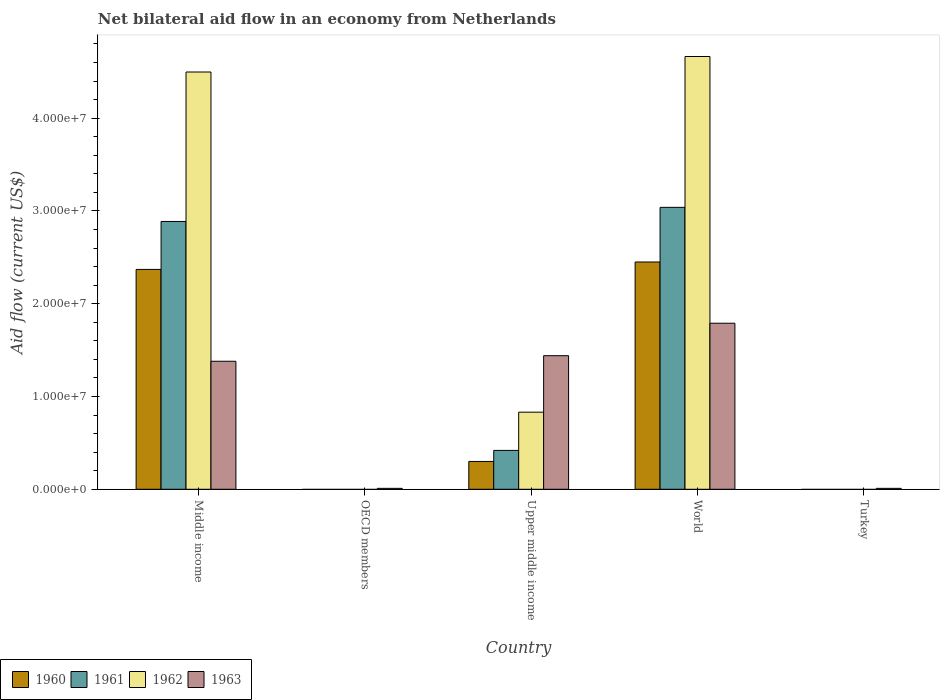How many different coloured bars are there?
Your response must be concise. 4. How many bars are there on the 4th tick from the left?
Your answer should be very brief. 4. How many bars are there on the 1st tick from the right?
Give a very brief answer. 1. What is the label of the 3rd group of bars from the left?
Make the answer very short. Upper middle income. In how many cases, is the number of bars for a given country not equal to the number of legend labels?
Offer a terse response. 2. What is the net bilateral aid flow in 1963 in Upper middle income?
Provide a succinct answer. 1.44e+07. Across all countries, what is the maximum net bilateral aid flow in 1962?
Your answer should be very brief. 4.66e+07. Across all countries, what is the minimum net bilateral aid flow in 1960?
Provide a short and direct response. 0. In which country was the net bilateral aid flow in 1963 maximum?
Offer a terse response. World. What is the total net bilateral aid flow in 1963 in the graph?
Give a very brief answer. 4.63e+07. What is the difference between the net bilateral aid flow in 1960 in Middle income and that in World?
Give a very brief answer. -8.00e+05. What is the difference between the net bilateral aid flow in 1960 in Upper middle income and the net bilateral aid flow in 1963 in World?
Provide a succinct answer. -1.49e+07. What is the average net bilateral aid flow in 1963 per country?
Offer a very short reply. 9.26e+06. What is the difference between the net bilateral aid flow of/in 1961 and net bilateral aid flow of/in 1960 in Middle income?
Your answer should be very brief. 5.17e+06. What is the ratio of the net bilateral aid flow in 1963 in Turkey to that in World?
Give a very brief answer. 0.01. Is the difference between the net bilateral aid flow in 1961 in Middle income and World greater than the difference between the net bilateral aid flow in 1960 in Middle income and World?
Offer a terse response. No. What is the difference between the highest and the second highest net bilateral aid flow in 1961?
Ensure brevity in your answer.  2.62e+07. What is the difference between the highest and the lowest net bilateral aid flow in 1962?
Provide a short and direct response. 4.66e+07. In how many countries, is the net bilateral aid flow in 1960 greater than the average net bilateral aid flow in 1960 taken over all countries?
Make the answer very short. 2. Is the sum of the net bilateral aid flow in 1963 in Turkey and World greater than the maximum net bilateral aid flow in 1961 across all countries?
Provide a succinct answer. No. Is it the case that in every country, the sum of the net bilateral aid flow in 1960 and net bilateral aid flow in 1961 is greater than the net bilateral aid flow in 1962?
Ensure brevity in your answer.  No. How many bars are there?
Your answer should be very brief. 14. Are all the bars in the graph horizontal?
Ensure brevity in your answer.  No. Does the graph contain any zero values?
Offer a terse response. Yes. Does the graph contain grids?
Keep it short and to the point. No. Where does the legend appear in the graph?
Your answer should be compact. Bottom left. What is the title of the graph?
Your answer should be compact. Net bilateral aid flow in an economy from Netherlands. Does "2000" appear as one of the legend labels in the graph?
Keep it short and to the point. No. What is the label or title of the X-axis?
Offer a terse response. Country. What is the Aid flow (current US$) in 1960 in Middle income?
Your answer should be very brief. 2.37e+07. What is the Aid flow (current US$) in 1961 in Middle income?
Your answer should be compact. 2.89e+07. What is the Aid flow (current US$) of 1962 in Middle income?
Your answer should be very brief. 4.50e+07. What is the Aid flow (current US$) of 1963 in Middle income?
Offer a terse response. 1.38e+07. What is the Aid flow (current US$) in 1961 in OECD members?
Offer a very short reply. 0. What is the Aid flow (current US$) of 1962 in OECD members?
Your response must be concise. 0. What is the Aid flow (current US$) in 1963 in OECD members?
Your answer should be very brief. 1.00e+05. What is the Aid flow (current US$) in 1961 in Upper middle income?
Offer a terse response. 4.19e+06. What is the Aid flow (current US$) in 1962 in Upper middle income?
Keep it short and to the point. 8.31e+06. What is the Aid flow (current US$) in 1963 in Upper middle income?
Your answer should be very brief. 1.44e+07. What is the Aid flow (current US$) in 1960 in World?
Your response must be concise. 2.45e+07. What is the Aid flow (current US$) in 1961 in World?
Your answer should be very brief. 3.04e+07. What is the Aid flow (current US$) of 1962 in World?
Ensure brevity in your answer.  4.66e+07. What is the Aid flow (current US$) of 1963 in World?
Offer a terse response. 1.79e+07. What is the Aid flow (current US$) of 1961 in Turkey?
Offer a terse response. 0. Across all countries, what is the maximum Aid flow (current US$) of 1960?
Your answer should be compact. 2.45e+07. Across all countries, what is the maximum Aid flow (current US$) in 1961?
Your answer should be compact. 3.04e+07. Across all countries, what is the maximum Aid flow (current US$) of 1962?
Ensure brevity in your answer.  4.66e+07. Across all countries, what is the maximum Aid flow (current US$) in 1963?
Keep it short and to the point. 1.79e+07. Across all countries, what is the minimum Aid flow (current US$) of 1960?
Give a very brief answer. 0. Across all countries, what is the minimum Aid flow (current US$) in 1963?
Provide a short and direct response. 1.00e+05. What is the total Aid flow (current US$) in 1960 in the graph?
Keep it short and to the point. 5.12e+07. What is the total Aid flow (current US$) of 1961 in the graph?
Keep it short and to the point. 6.34e+07. What is the total Aid flow (current US$) of 1962 in the graph?
Provide a short and direct response. 9.99e+07. What is the total Aid flow (current US$) in 1963 in the graph?
Keep it short and to the point. 4.63e+07. What is the difference between the Aid flow (current US$) in 1963 in Middle income and that in OECD members?
Your answer should be very brief. 1.37e+07. What is the difference between the Aid flow (current US$) of 1960 in Middle income and that in Upper middle income?
Give a very brief answer. 2.07e+07. What is the difference between the Aid flow (current US$) of 1961 in Middle income and that in Upper middle income?
Your response must be concise. 2.47e+07. What is the difference between the Aid flow (current US$) in 1962 in Middle income and that in Upper middle income?
Your answer should be very brief. 3.67e+07. What is the difference between the Aid flow (current US$) of 1963 in Middle income and that in Upper middle income?
Provide a short and direct response. -6.00e+05. What is the difference between the Aid flow (current US$) in 1960 in Middle income and that in World?
Offer a terse response. -8.00e+05. What is the difference between the Aid flow (current US$) in 1961 in Middle income and that in World?
Provide a succinct answer. -1.52e+06. What is the difference between the Aid flow (current US$) in 1962 in Middle income and that in World?
Make the answer very short. -1.67e+06. What is the difference between the Aid flow (current US$) in 1963 in Middle income and that in World?
Make the answer very short. -4.10e+06. What is the difference between the Aid flow (current US$) in 1963 in Middle income and that in Turkey?
Offer a terse response. 1.37e+07. What is the difference between the Aid flow (current US$) of 1963 in OECD members and that in Upper middle income?
Your answer should be very brief. -1.43e+07. What is the difference between the Aid flow (current US$) in 1963 in OECD members and that in World?
Provide a short and direct response. -1.78e+07. What is the difference between the Aid flow (current US$) of 1963 in OECD members and that in Turkey?
Provide a succinct answer. 0. What is the difference between the Aid flow (current US$) of 1960 in Upper middle income and that in World?
Ensure brevity in your answer.  -2.15e+07. What is the difference between the Aid flow (current US$) in 1961 in Upper middle income and that in World?
Your answer should be compact. -2.62e+07. What is the difference between the Aid flow (current US$) in 1962 in Upper middle income and that in World?
Your answer should be very brief. -3.83e+07. What is the difference between the Aid flow (current US$) in 1963 in Upper middle income and that in World?
Give a very brief answer. -3.50e+06. What is the difference between the Aid flow (current US$) in 1963 in Upper middle income and that in Turkey?
Give a very brief answer. 1.43e+07. What is the difference between the Aid flow (current US$) in 1963 in World and that in Turkey?
Give a very brief answer. 1.78e+07. What is the difference between the Aid flow (current US$) in 1960 in Middle income and the Aid flow (current US$) in 1963 in OECD members?
Your response must be concise. 2.36e+07. What is the difference between the Aid flow (current US$) of 1961 in Middle income and the Aid flow (current US$) of 1963 in OECD members?
Give a very brief answer. 2.88e+07. What is the difference between the Aid flow (current US$) in 1962 in Middle income and the Aid flow (current US$) in 1963 in OECD members?
Make the answer very short. 4.49e+07. What is the difference between the Aid flow (current US$) of 1960 in Middle income and the Aid flow (current US$) of 1961 in Upper middle income?
Give a very brief answer. 1.95e+07. What is the difference between the Aid flow (current US$) in 1960 in Middle income and the Aid flow (current US$) in 1962 in Upper middle income?
Offer a very short reply. 1.54e+07. What is the difference between the Aid flow (current US$) of 1960 in Middle income and the Aid flow (current US$) of 1963 in Upper middle income?
Offer a terse response. 9.30e+06. What is the difference between the Aid flow (current US$) in 1961 in Middle income and the Aid flow (current US$) in 1962 in Upper middle income?
Provide a succinct answer. 2.06e+07. What is the difference between the Aid flow (current US$) in 1961 in Middle income and the Aid flow (current US$) in 1963 in Upper middle income?
Your answer should be compact. 1.45e+07. What is the difference between the Aid flow (current US$) of 1962 in Middle income and the Aid flow (current US$) of 1963 in Upper middle income?
Your answer should be compact. 3.06e+07. What is the difference between the Aid flow (current US$) in 1960 in Middle income and the Aid flow (current US$) in 1961 in World?
Make the answer very short. -6.69e+06. What is the difference between the Aid flow (current US$) of 1960 in Middle income and the Aid flow (current US$) of 1962 in World?
Your response must be concise. -2.30e+07. What is the difference between the Aid flow (current US$) of 1960 in Middle income and the Aid flow (current US$) of 1963 in World?
Keep it short and to the point. 5.80e+06. What is the difference between the Aid flow (current US$) of 1961 in Middle income and the Aid flow (current US$) of 1962 in World?
Offer a very short reply. -1.78e+07. What is the difference between the Aid flow (current US$) of 1961 in Middle income and the Aid flow (current US$) of 1963 in World?
Your answer should be compact. 1.10e+07. What is the difference between the Aid flow (current US$) in 1962 in Middle income and the Aid flow (current US$) in 1963 in World?
Your response must be concise. 2.71e+07. What is the difference between the Aid flow (current US$) of 1960 in Middle income and the Aid flow (current US$) of 1963 in Turkey?
Give a very brief answer. 2.36e+07. What is the difference between the Aid flow (current US$) of 1961 in Middle income and the Aid flow (current US$) of 1963 in Turkey?
Your answer should be compact. 2.88e+07. What is the difference between the Aid flow (current US$) of 1962 in Middle income and the Aid flow (current US$) of 1963 in Turkey?
Provide a succinct answer. 4.49e+07. What is the difference between the Aid flow (current US$) in 1960 in Upper middle income and the Aid flow (current US$) in 1961 in World?
Make the answer very short. -2.74e+07. What is the difference between the Aid flow (current US$) of 1960 in Upper middle income and the Aid flow (current US$) of 1962 in World?
Provide a short and direct response. -4.36e+07. What is the difference between the Aid flow (current US$) of 1960 in Upper middle income and the Aid flow (current US$) of 1963 in World?
Your answer should be compact. -1.49e+07. What is the difference between the Aid flow (current US$) of 1961 in Upper middle income and the Aid flow (current US$) of 1962 in World?
Give a very brief answer. -4.25e+07. What is the difference between the Aid flow (current US$) of 1961 in Upper middle income and the Aid flow (current US$) of 1963 in World?
Your answer should be very brief. -1.37e+07. What is the difference between the Aid flow (current US$) of 1962 in Upper middle income and the Aid flow (current US$) of 1963 in World?
Provide a short and direct response. -9.59e+06. What is the difference between the Aid flow (current US$) of 1960 in Upper middle income and the Aid flow (current US$) of 1963 in Turkey?
Provide a short and direct response. 2.90e+06. What is the difference between the Aid flow (current US$) in 1961 in Upper middle income and the Aid flow (current US$) in 1963 in Turkey?
Your answer should be very brief. 4.09e+06. What is the difference between the Aid flow (current US$) in 1962 in Upper middle income and the Aid flow (current US$) in 1963 in Turkey?
Your answer should be very brief. 8.21e+06. What is the difference between the Aid flow (current US$) of 1960 in World and the Aid flow (current US$) of 1963 in Turkey?
Your answer should be very brief. 2.44e+07. What is the difference between the Aid flow (current US$) of 1961 in World and the Aid flow (current US$) of 1963 in Turkey?
Your answer should be very brief. 3.03e+07. What is the difference between the Aid flow (current US$) of 1962 in World and the Aid flow (current US$) of 1963 in Turkey?
Your answer should be very brief. 4.66e+07. What is the average Aid flow (current US$) in 1960 per country?
Make the answer very short. 1.02e+07. What is the average Aid flow (current US$) of 1961 per country?
Keep it short and to the point. 1.27e+07. What is the average Aid flow (current US$) in 1962 per country?
Ensure brevity in your answer.  2.00e+07. What is the average Aid flow (current US$) in 1963 per country?
Give a very brief answer. 9.26e+06. What is the difference between the Aid flow (current US$) of 1960 and Aid flow (current US$) of 1961 in Middle income?
Your answer should be compact. -5.17e+06. What is the difference between the Aid flow (current US$) in 1960 and Aid flow (current US$) in 1962 in Middle income?
Provide a succinct answer. -2.13e+07. What is the difference between the Aid flow (current US$) in 1960 and Aid flow (current US$) in 1963 in Middle income?
Keep it short and to the point. 9.90e+06. What is the difference between the Aid flow (current US$) of 1961 and Aid flow (current US$) of 1962 in Middle income?
Your answer should be compact. -1.61e+07. What is the difference between the Aid flow (current US$) of 1961 and Aid flow (current US$) of 1963 in Middle income?
Provide a short and direct response. 1.51e+07. What is the difference between the Aid flow (current US$) in 1962 and Aid flow (current US$) in 1963 in Middle income?
Ensure brevity in your answer.  3.12e+07. What is the difference between the Aid flow (current US$) in 1960 and Aid flow (current US$) in 1961 in Upper middle income?
Offer a very short reply. -1.19e+06. What is the difference between the Aid flow (current US$) in 1960 and Aid flow (current US$) in 1962 in Upper middle income?
Your response must be concise. -5.31e+06. What is the difference between the Aid flow (current US$) in 1960 and Aid flow (current US$) in 1963 in Upper middle income?
Your answer should be compact. -1.14e+07. What is the difference between the Aid flow (current US$) in 1961 and Aid flow (current US$) in 1962 in Upper middle income?
Provide a succinct answer. -4.12e+06. What is the difference between the Aid flow (current US$) in 1961 and Aid flow (current US$) in 1963 in Upper middle income?
Give a very brief answer. -1.02e+07. What is the difference between the Aid flow (current US$) in 1962 and Aid flow (current US$) in 1963 in Upper middle income?
Your response must be concise. -6.09e+06. What is the difference between the Aid flow (current US$) of 1960 and Aid flow (current US$) of 1961 in World?
Provide a short and direct response. -5.89e+06. What is the difference between the Aid flow (current US$) in 1960 and Aid flow (current US$) in 1962 in World?
Offer a terse response. -2.22e+07. What is the difference between the Aid flow (current US$) of 1960 and Aid flow (current US$) of 1963 in World?
Give a very brief answer. 6.60e+06. What is the difference between the Aid flow (current US$) in 1961 and Aid flow (current US$) in 1962 in World?
Your answer should be very brief. -1.63e+07. What is the difference between the Aid flow (current US$) of 1961 and Aid flow (current US$) of 1963 in World?
Provide a succinct answer. 1.25e+07. What is the difference between the Aid flow (current US$) in 1962 and Aid flow (current US$) in 1963 in World?
Your answer should be compact. 2.88e+07. What is the ratio of the Aid flow (current US$) of 1963 in Middle income to that in OECD members?
Offer a terse response. 138. What is the ratio of the Aid flow (current US$) in 1960 in Middle income to that in Upper middle income?
Your answer should be very brief. 7.9. What is the ratio of the Aid flow (current US$) of 1961 in Middle income to that in Upper middle income?
Make the answer very short. 6.89. What is the ratio of the Aid flow (current US$) in 1962 in Middle income to that in Upper middle income?
Offer a terse response. 5.41. What is the ratio of the Aid flow (current US$) of 1960 in Middle income to that in World?
Ensure brevity in your answer.  0.97. What is the ratio of the Aid flow (current US$) in 1962 in Middle income to that in World?
Offer a very short reply. 0.96. What is the ratio of the Aid flow (current US$) in 1963 in Middle income to that in World?
Offer a very short reply. 0.77. What is the ratio of the Aid flow (current US$) of 1963 in Middle income to that in Turkey?
Offer a very short reply. 138. What is the ratio of the Aid flow (current US$) in 1963 in OECD members to that in Upper middle income?
Ensure brevity in your answer.  0.01. What is the ratio of the Aid flow (current US$) in 1963 in OECD members to that in World?
Your response must be concise. 0.01. What is the ratio of the Aid flow (current US$) in 1960 in Upper middle income to that in World?
Keep it short and to the point. 0.12. What is the ratio of the Aid flow (current US$) in 1961 in Upper middle income to that in World?
Offer a terse response. 0.14. What is the ratio of the Aid flow (current US$) in 1962 in Upper middle income to that in World?
Ensure brevity in your answer.  0.18. What is the ratio of the Aid flow (current US$) in 1963 in Upper middle income to that in World?
Keep it short and to the point. 0.8. What is the ratio of the Aid flow (current US$) in 1963 in Upper middle income to that in Turkey?
Make the answer very short. 144. What is the ratio of the Aid flow (current US$) of 1963 in World to that in Turkey?
Keep it short and to the point. 179. What is the difference between the highest and the second highest Aid flow (current US$) in 1961?
Make the answer very short. 1.52e+06. What is the difference between the highest and the second highest Aid flow (current US$) in 1962?
Ensure brevity in your answer.  1.67e+06. What is the difference between the highest and the second highest Aid flow (current US$) of 1963?
Provide a succinct answer. 3.50e+06. What is the difference between the highest and the lowest Aid flow (current US$) of 1960?
Offer a very short reply. 2.45e+07. What is the difference between the highest and the lowest Aid flow (current US$) of 1961?
Keep it short and to the point. 3.04e+07. What is the difference between the highest and the lowest Aid flow (current US$) of 1962?
Your answer should be very brief. 4.66e+07. What is the difference between the highest and the lowest Aid flow (current US$) of 1963?
Provide a succinct answer. 1.78e+07. 